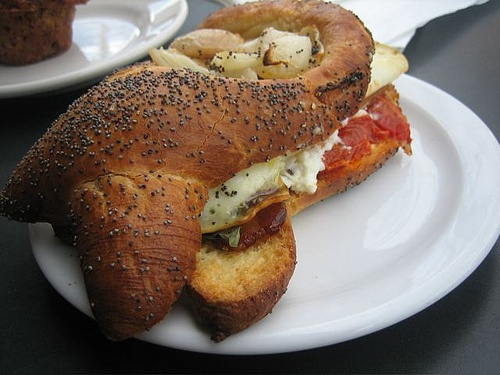Describe the objects in this image and their specific colors. I can see sandwich in black, brown, maroon, and gray tones and dining table in black, gray, and purple tones in this image. 